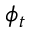<formula> <loc_0><loc_0><loc_500><loc_500>\phi _ { t }</formula> 